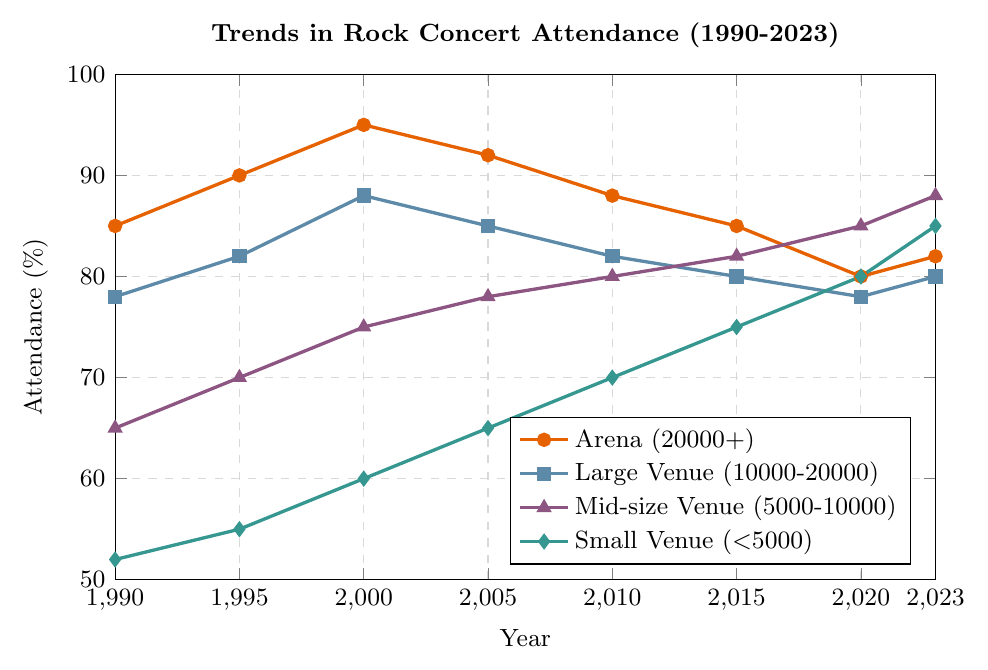what's the average attendance at Arena (20000+) venues over the 30 years? Sum the attendance rates for Arena (20000+) venues across all years: 85 + 90 + 95 + 92 + 88 + 85 + 80 + 82 = 697. There are 8 data points, so the average is 697 / 8 = 87.125
Answer: 87.125 How did attendance in Mid-size Venue (5000-10000) change from 1990 to 2023? Attendance at Mid-size Venue (5000-10000) was 65 in 1990 and 88 in 2023. The change is 88 - 65 = 23.
Answer: Increased by 23 Which venue type saw the greatest increase in attendance from 1990 to 2023? Calculate the difference between 1990 and 2023 for each venue type: 
- Arena: 82 - 85 = -3 
- Large Venue: 80 - 78 = 2 
- Mid-size Venue: 88 - 65 = 23 
- Small Venue: 85 - 52 = 33 
The greatest increase is in Small Venue (\<5000) with an increase of 33.
Answer: Small Venue (<5000) In which year did Small Venue (\<5000) attendance equal Large Venue (10000-20000) attendance? Scan the data for equal values: 
In 2020, both Small Venue (\<5000) and Large Venue (10000-20000) had an attendance of 80.
Answer: 2020 What is the trend in Arena (20000+) attendance from 2000 to 2020? From 2000 to 2020, the attendance values are:
- 2000: 95
- 2005: 92
- 2010: 88
- 2015: 85
- 2020: 80
The trend shows a consistent decline over these years.
Answer: Decline What's the difference in attendance between Small Venue (\<5000) and Arena (20000+) in the year 2023? Small Venue (\<5000) had an attendance of 85 and Arena (20000+) had 82 in 2023. The difference is 85 - 82 = 3.
Answer: 3 Compare the attendance trends for Mid-size Venue (5000-10000) and Large Venue (10000-20000) from 2010 to 2023. From 2010 to 2023:
- Mid-size Venue (5000-10000): 80, 82, 85, 88 (Increasing trend)
- Large Venue (10000-20000): 82, 80, 78, 80 (Slight decline, then increase)
Mid-size Venue shows a consistent increase, while Large Venue shows a slight decline followed by a slight increase.
Answer: Mid-size: Increase, Large: Fluctuating Which year did attendance in Mid-size Venue (5000-10000) surpass attendance in Arena (20000+)? Comparing consecutive years:
In 2015, Mid-size (82) was slightly behind Arena (85). 
In 2020, Mid-size (85) surpassed Arena (80). 
So, in 2020, the attendance in Mid-size surpassed Arena.
Answer: 2020 Which venue type had the smallest range in attendance values from 1990 to 2023? Calculate the range (difference between highest and lowest values):
- Arena (20000+): Max (95), Min (80) -> Range = 95 - 80 = 15
- Large Venue (10000-20000): Max (88), Min (78) -> Range = 88 - 78 = 10
- Mid-size Venue (5000-10000): Max (88), Min (65) -> Range = 88 - 65 = 23
- Small Venue (\<5000): Max (85), Min (52) -> Range = 85 - 52 = 33
The smallest range is for Large Venue (10000-20000) with a range of 10.
Answer: Large Venue (10000-20000) How much higher was the Small Venue (\<5000) attendance in 2023 compared to 1990? Small Venue attendance in 1990 was 52 and in 2023 was 85. The difference is 85 - 52 = 33.
Answer: 33 